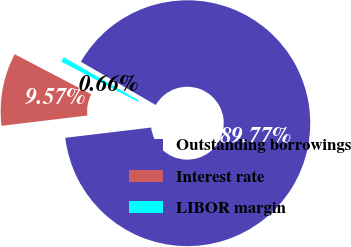Convert chart to OTSL. <chart><loc_0><loc_0><loc_500><loc_500><pie_chart><fcel>Outstanding borrowings<fcel>Interest rate<fcel>LIBOR margin<nl><fcel>89.77%<fcel>9.57%<fcel>0.66%<nl></chart> 